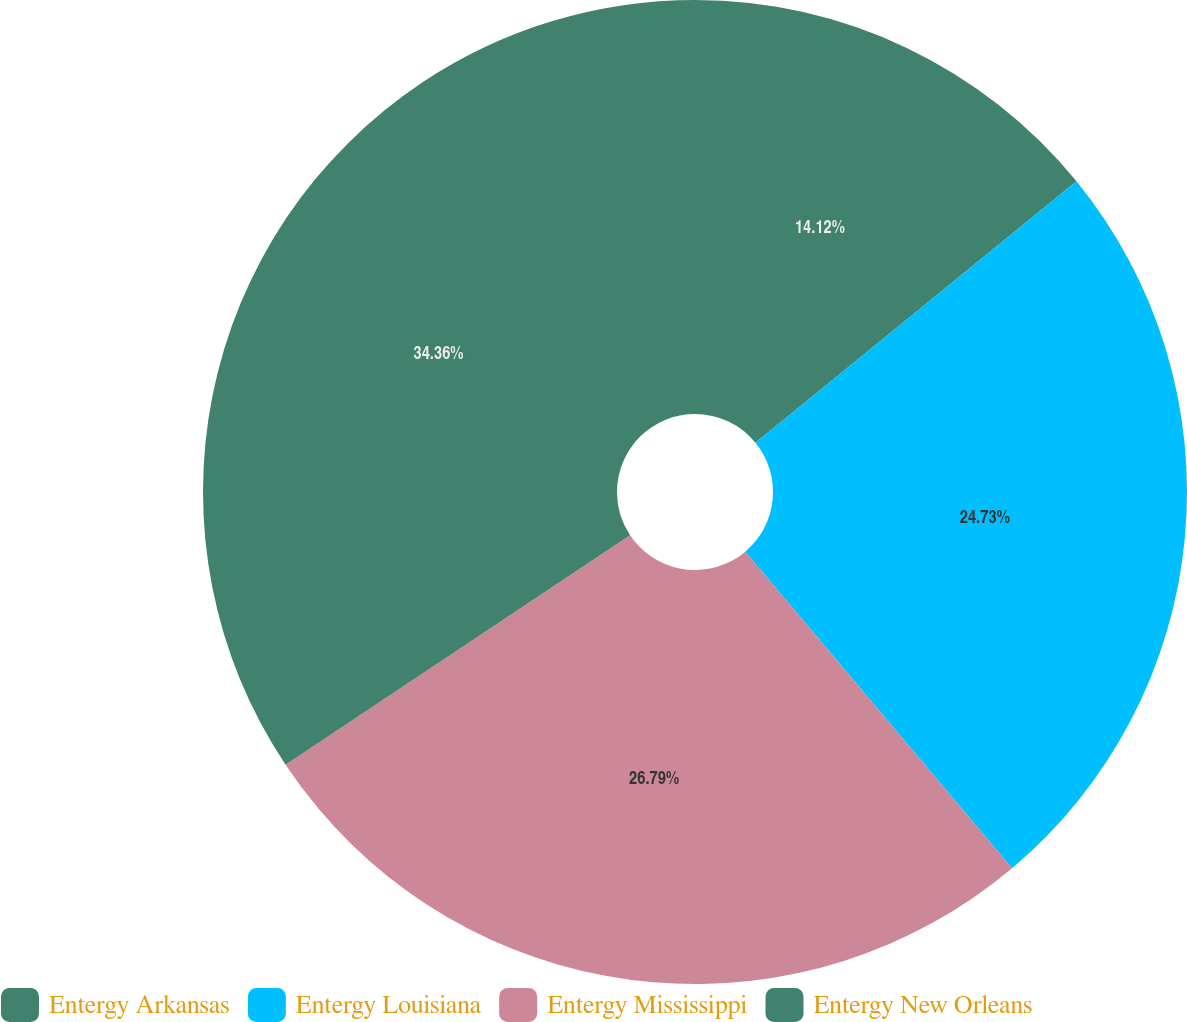<chart> <loc_0><loc_0><loc_500><loc_500><pie_chart><fcel>Entergy Arkansas<fcel>Entergy Louisiana<fcel>Entergy Mississippi<fcel>Entergy New Orleans<nl><fcel>14.12%<fcel>24.73%<fcel>26.79%<fcel>34.35%<nl></chart> 